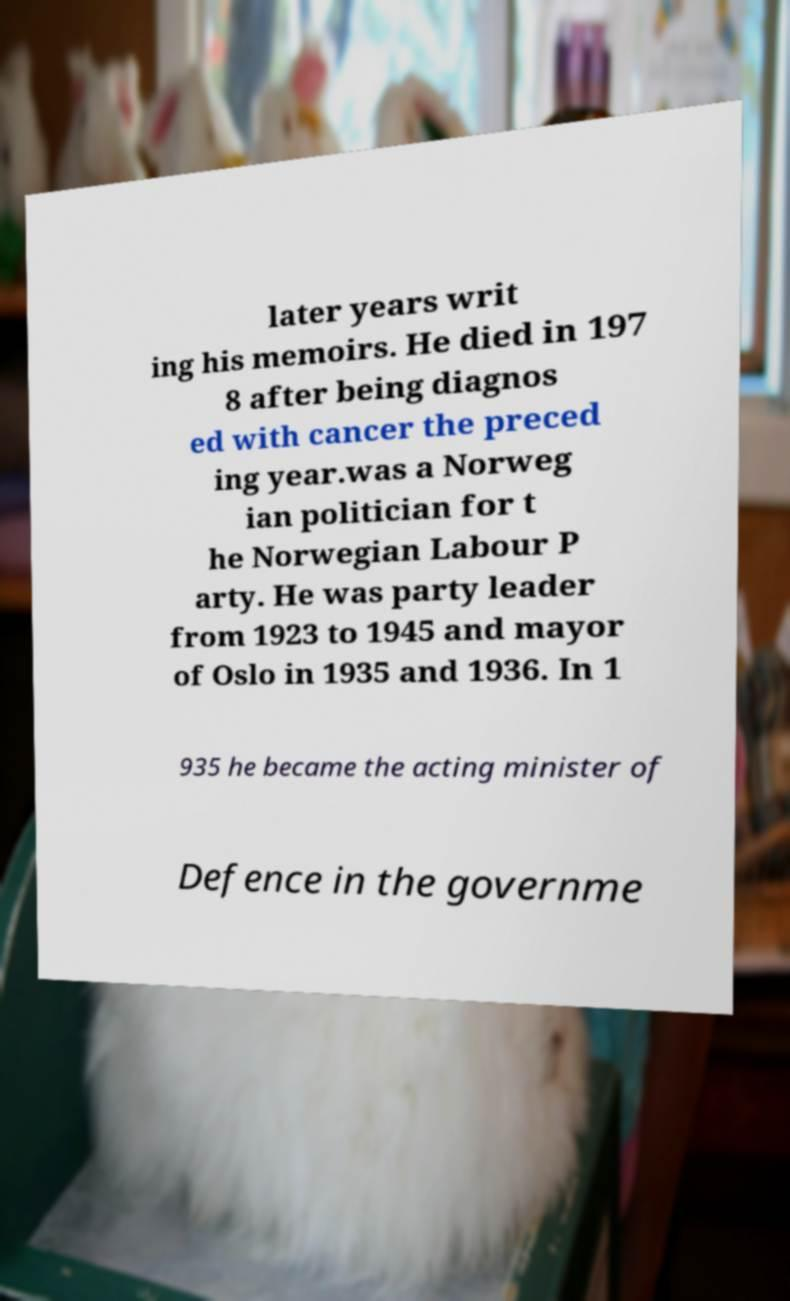Please read and relay the text visible in this image. What does it say? later years writ ing his memoirs. He died in 197 8 after being diagnos ed with cancer the preced ing year.was a Norweg ian politician for t he Norwegian Labour P arty. He was party leader from 1923 to 1945 and mayor of Oslo in 1935 and 1936. In 1 935 he became the acting minister of Defence in the governme 